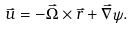<formula> <loc_0><loc_0><loc_500><loc_500>\vec { u } = - \vec { \Omega } \times \vec { r } + \vec { \nabla } \psi .</formula> 